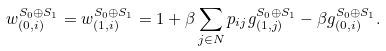Convert formula to latex. <formula><loc_0><loc_0><loc_500><loc_500>w ^ { S _ { 0 } \oplus S _ { 1 } } _ { ( 0 , i ) } = w ^ { S _ { 0 } \oplus S _ { 1 } } _ { ( 1 , i ) } = 1 + \beta \sum _ { j \in N } p _ { i j } g ^ { S _ { 0 } \oplus S _ { 1 } } _ { ( 1 , j ) } - \beta g ^ { S _ { 0 } \oplus S _ { 1 } } _ { ( 0 , i ) } .</formula> 